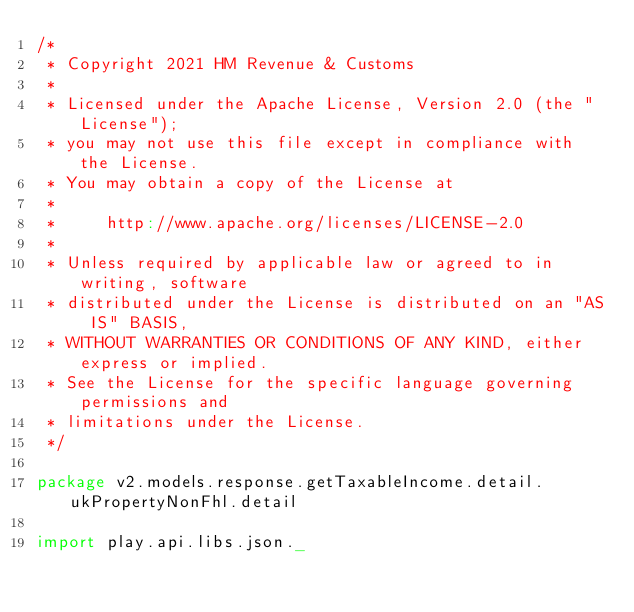<code> <loc_0><loc_0><loc_500><loc_500><_Scala_>/*
 * Copyright 2021 HM Revenue & Customs
 *
 * Licensed under the Apache License, Version 2.0 (the "License");
 * you may not use this file except in compliance with the License.
 * You may obtain a copy of the License at
 *
 *     http://www.apache.org/licenses/LICENSE-2.0
 *
 * Unless required by applicable law or agreed to in writing, software
 * distributed under the License is distributed on an "AS IS" BASIS,
 * WITHOUT WARRANTIES OR CONDITIONS OF ANY KIND, either express or implied.
 * See the License for the specific language governing permissions and
 * limitations under the License.
 */

package v2.models.response.getTaxableIncome.detail.ukPropertyNonFhl.detail

import play.api.libs.json._
</code> 